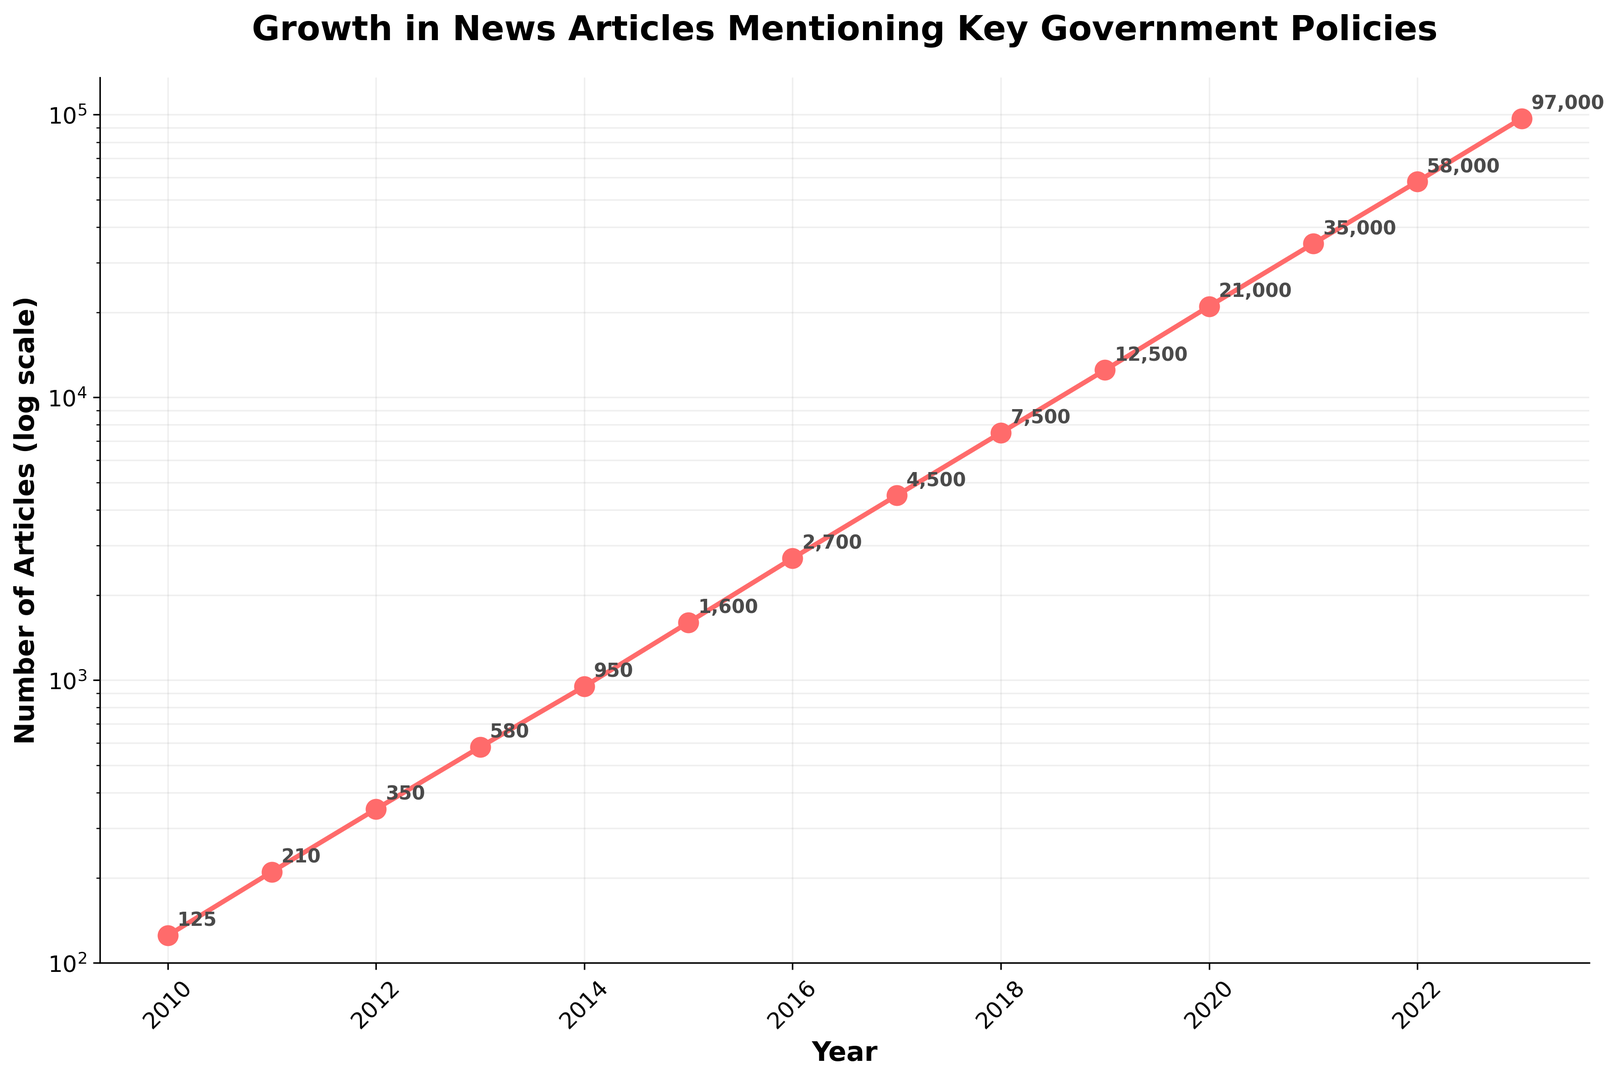What is the overall trend in the number of news articles mentioning key government policies from 2010 to 2023? The figure shows a consistent increase in the number of news articles each year. By observing the upward trend line, we can confirm this continuous growth.
Answer: Continuous growth How many more articles were published in 2021 compared to 2010? In 2010, there were 125 articles and in 2021, there were 35,000 articles. The difference is 35,000 - 125.
Answer: 34,875 Which year saw the highest number of articles? The year with the highest point on the figure represents the highest number of articles, which is clearly 2023.
Answer: 2023 What is the approximate rate of increase in the number of articles between 2010 and 2023? The figure's logarithmic scale indicates a rapid acceleration in the number of articles. Analyzing the data, we can see it grows exponentially. From 125 articles in 2010 to 97,000 articles in 2023, the growth rate is significant.
Answer: Exponential growth In which year did the number of articles first exceed 10,000? Following the logarithmic scale plot, we observe that the number of articles surpassed 10,000 in 2019.
Answer: 2019 Which years saw the number of articles double compared to the previous year? Observing the steep movements on the logarithmic scale, particularly between consecutive years, we notice significant increases. This doubling effect is apparent from 2019 (12,500) to 2020 (21,000) and 2022 (58,000) to 2023 (97,000).
Answer: 2019-2020 and 2022-2023 What is the average number of articles published per year from 2010 to 2023? Sum all articles from 2010 to 2023 {125 + 210 + 350 + 580 + 950 + 1600 + 2700 + 4500 + 7500 + 12500 + 21000 + 35000 + 58000 + 97000} = 245,015. Divide by 14 years.
Answer: 17,501 Which year had the smallest increase in the number of articles compared to the previous year? The year-by-year inspection of data reveals that the smallest increase was from 2011 (210) to 2012 (350), with an increase of 140 articles.
Answer: 2012 Is the growth pattern in the number of articles steady, or are there any noticeable fluctuations? By analyzing the plot's general upward trend, occasional noticeable bumps indicate fluctuations, but the overall pattern remains steadily increasing. This can be attributed to the logarithmic scale representing exponential growth more straightforwardly.
Answer: Steady with minor fluctuations 